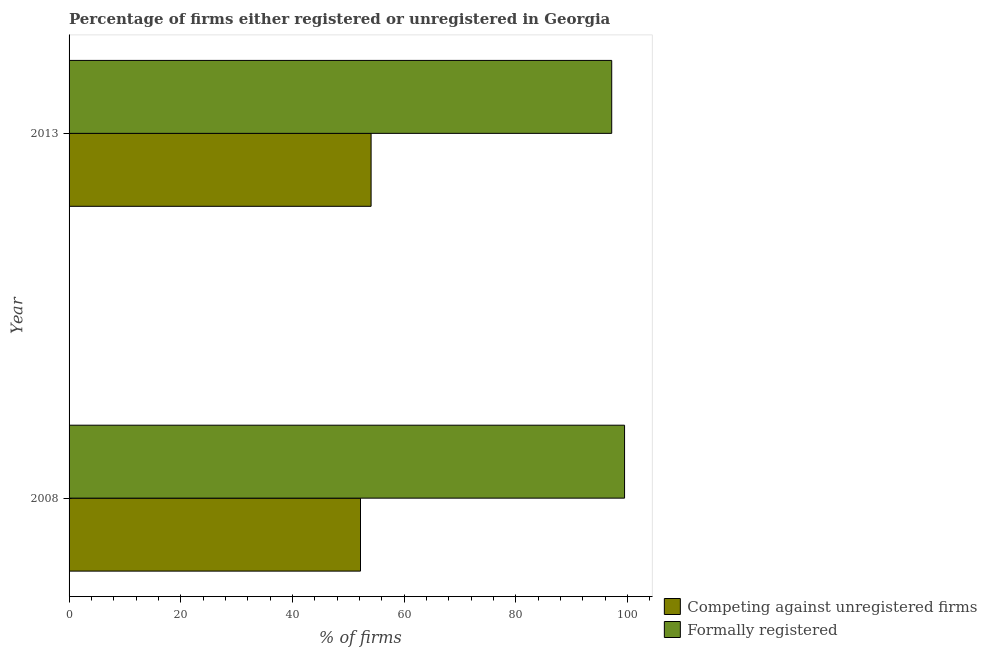How many groups of bars are there?
Make the answer very short. 2. Are the number of bars per tick equal to the number of legend labels?
Provide a succinct answer. Yes. How many bars are there on the 2nd tick from the top?
Provide a succinct answer. 2. In how many cases, is the number of bars for a given year not equal to the number of legend labels?
Your answer should be compact. 0. What is the percentage of formally registered firms in 2013?
Ensure brevity in your answer.  97.2. Across all years, what is the maximum percentage of registered firms?
Keep it short and to the point. 54.1. Across all years, what is the minimum percentage of formally registered firms?
Make the answer very short. 97.2. What is the total percentage of formally registered firms in the graph?
Your response must be concise. 196.7. What is the difference between the percentage of registered firms in 2008 and that in 2013?
Give a very brief answer. -1.9. What is the difference between the percentage of formally registered firms in 2008 and the percentage of registered firms in 2013?
Your response must be concise. 45.4. What is the average percentage of registered firms per year?
Keep it short and to the point. 53.15. In the year 2013, what is the difference between the percentage of registered firms and percentage of formally registered firms?
Offer a very short reply. -43.1. In how many years, is the percentage of formally registered firms greater than 16 %?
Ensure brevity in your answer.  2. What is the ratio of the percentage of registered firms in 2008 to that in 2013?
Your answer should be compact. 0.96. Is the percentage of formally registered firms in 2008 less than that in 2013?
Give a very brief answer. No. In how many years, is the percentage of formally registered firms greater than the average percentage of formally registered firms taken over all years?
Ensure brevity in your answer.  1. What does the 2nd bar from the top in 2008 represents?
Your response must be concise. Competing against unregistered firms. What does the 2nd bar from the bottom in 2013 represents?
Offer a very short reply. Formally registered. Are all the bars in the graph horizontal?
Offer a very short reply. Yes. Are the values on the major ticks of X-axis written in scientific E-notation?
Your answer should be compact. No. How many legend labels are there?
Provide a succinct answer. 2. How are the legend labels stacked?
Provide a short and direct response. Vertical. What is the title of the graph?
Your answer should be compact. Percentage of firms either registered or unregistered in Georgia. Does "% of gross capital formation" appear as one of the legend labels in the graph?
Give a very brief answer. No. What is the label or title of the X-axis?
Give a very brief answer. % of firms. What is the label or title of the Y-axis?
Ensure brevity in your answer.  Year. What is the % of firms of Competing against unregistered firms in 2008?
Ensure brevity in your answer.  52.2. What is the % of firms of Formally registered in 2008?
Make the answer very short. 99.5. What is the % of firms in Competing against unregistered firms in 2013?
Your answer should be compact. 54.1. What is the % of firms of Formally registered in 2013?
Offer a terse response. 97.2. Across all years, what is the maximum % of firms of Competing against unregistered firms?
Ensure brevity in your answer.  54.1. Across all years, what is the maximum % of firms in Formally registered?
Provide a succinct answer. 99.5. Across all years, what is the minimum % of firms of Competing against unregistered firms?
Ensure brevity in your answer.  52.2. Across all years, what is the minimum % of firms in Formally registered?
Your answer should be compact. 97.2. What is the total % of firms of Competing against unregistered firms in the graph?
Your answer should be very brief. 106.3. What is the total % of firms in Formally registered in the graph?
Provide a succinct answer. 196.7. What is the difference between the % of firms of Formally registered in 2008 and that in 2013?
Your answer should be very brief. 2.3. What is the difference between the % of firms of Competing against unregistered firms in 2008 and the % of firms of Formally registered in 2013?
Make the answer very short. -45. What is the average % of firms of Competing against unregistered firms per year?
Ensure brevity in your answer.  53.15. What is the average % of firms in Formally registered per year?
Offer a terse response. 98.35. In the year 2008, what is the difference between the % of firms in Competing against unregistered firms and % of firms in Formally registered?
Offer a terse response. -47.3. In the year 2013, what is the difference between the % of firms of Competing against unregistered firms and % of firms of Formally registered?
Provide a succinct answer. -43.1. What is the ratio of the % of firms of Competing against unregistered firms in 2008 to that in 2013?
Your response must be concise. 0.96. What is the ratio of the % of firms of Formally registered in 2008 to that in 2013?
Offer a terse response. 1.02. What is the difference between the highest and the lowest % of firms of Formally registered?
Offer a very short reply. 2.3. 